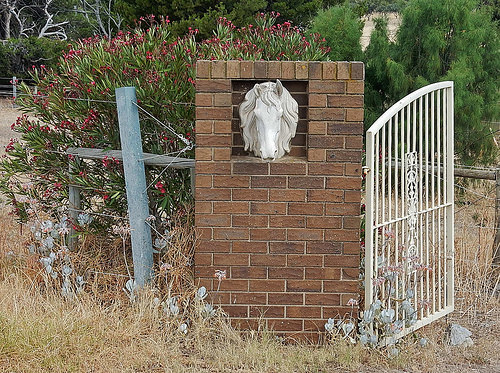<image>
Can you confirm if the horse is in the wall? Yes. The horse is contained within or inside the wall, showing a containment relationship. Is the bushes in front of the gate? No. The bushes is not in front of the gate. The spatial positioning shows a different relationship between these objects. 